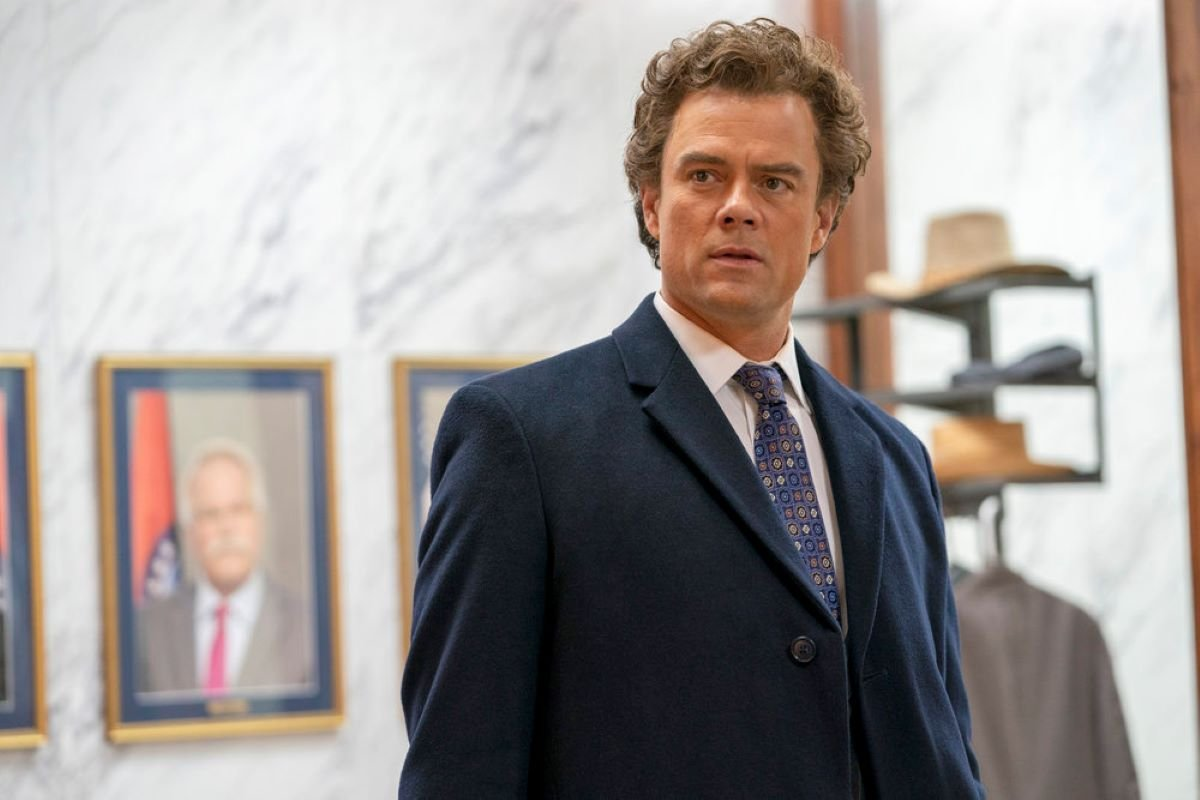What might be the significance of the documents or pictures on the wall behind the man? The framed pictures and documents behind the individual are likely accolades or certificates, which could imply that the setting is a place of distinguished activity, possibly an office or institution where academic, professional, or civic achievements are recognized. These elements enhance the room's dignified ambiance and subtly hint at the accomplishments or the status of the individuals associated with this environment. 